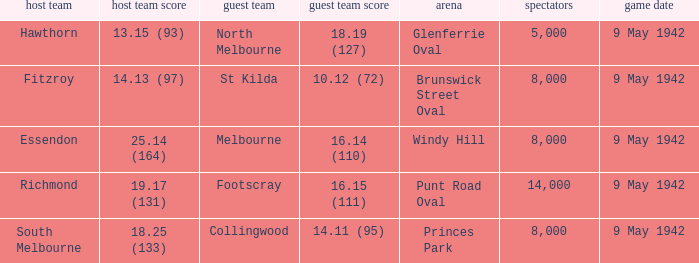How many people attended the game where Footscray was away? 14000.0. 